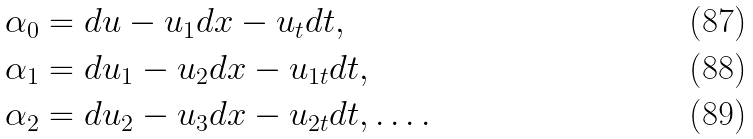<formula> <loc_0><loc_0><loc_500><loc_500>\alpha _ { 0 } & = d u - u _ { 1 } d x - u _ { t } d t , \\ \alpha _ { 1 } & = d u _ { 1 } - u _ { 2 } d x - u _ { 1 t } d t , \\ \alpha _ { 2 } & = d u _ { 2 } - u _ { 3 } d x - u _ { 2 t } d t , \dots .</formula> 